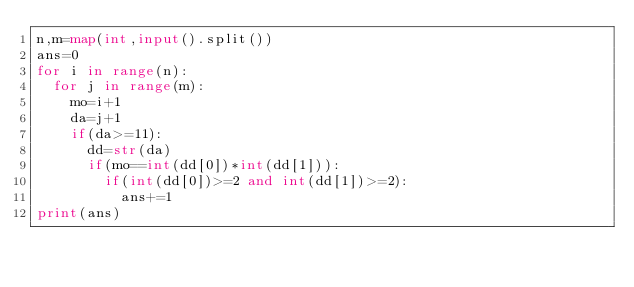Convert code to text. <code><loc_0><loc_0><loc_500><loc_500><_Python_>n,m=map(int,input().split())
ans=0
for i in range(n):
  for j in range(m):
    mo=i+1
    da=j+1
    if(da>=11):
      dd=str(da)
      if(mo==int(dd[0])*int(dd[1])):
        if(int(dd[0])>=2 and int(dd[1])>=2):
          ans+=1
print(ans)</code> 